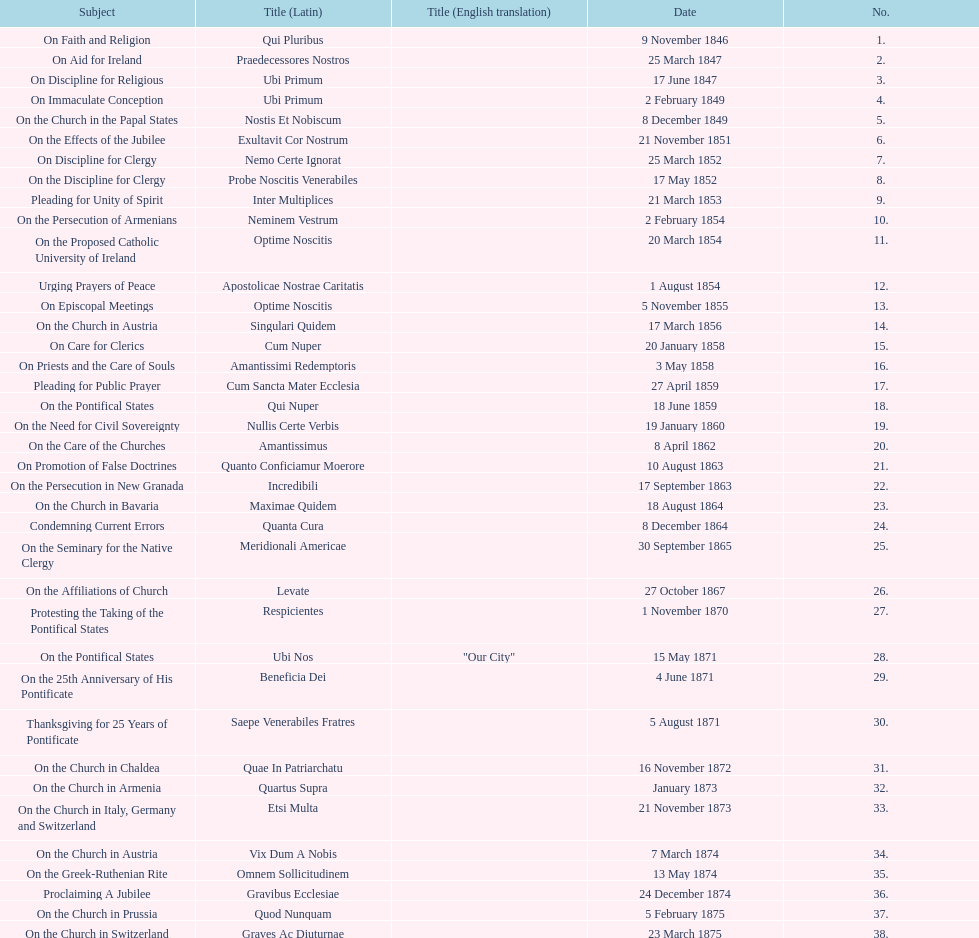How many subjects are there? 38. 